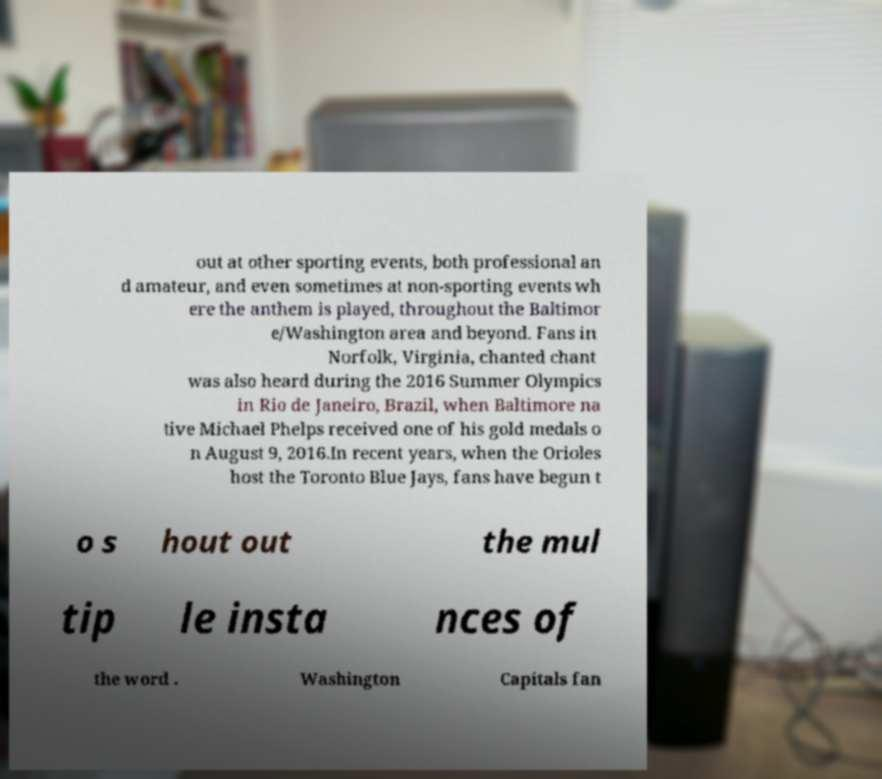Please read and relay the text visible in this image. What does it say? out at other sporting events, both professional an d amateur, and even sometimes at non-sporting events wh ere the anthem is played, throughout the Baltimor e/Washington area and beyond. Fans in Norfolk, Virginia, chanted chant was also heard during the 2016 Summer Olympics in Rio de Janeiro, Brazil, when Baltimore na tive Michael Phelps received one of his gold medals o n August 9, 2016.In recent years, when the Orioles host the Toronto Blue Jays, fans have begun t o s hout out the mul tip le insta nces of the word . Washington Capitals fan 